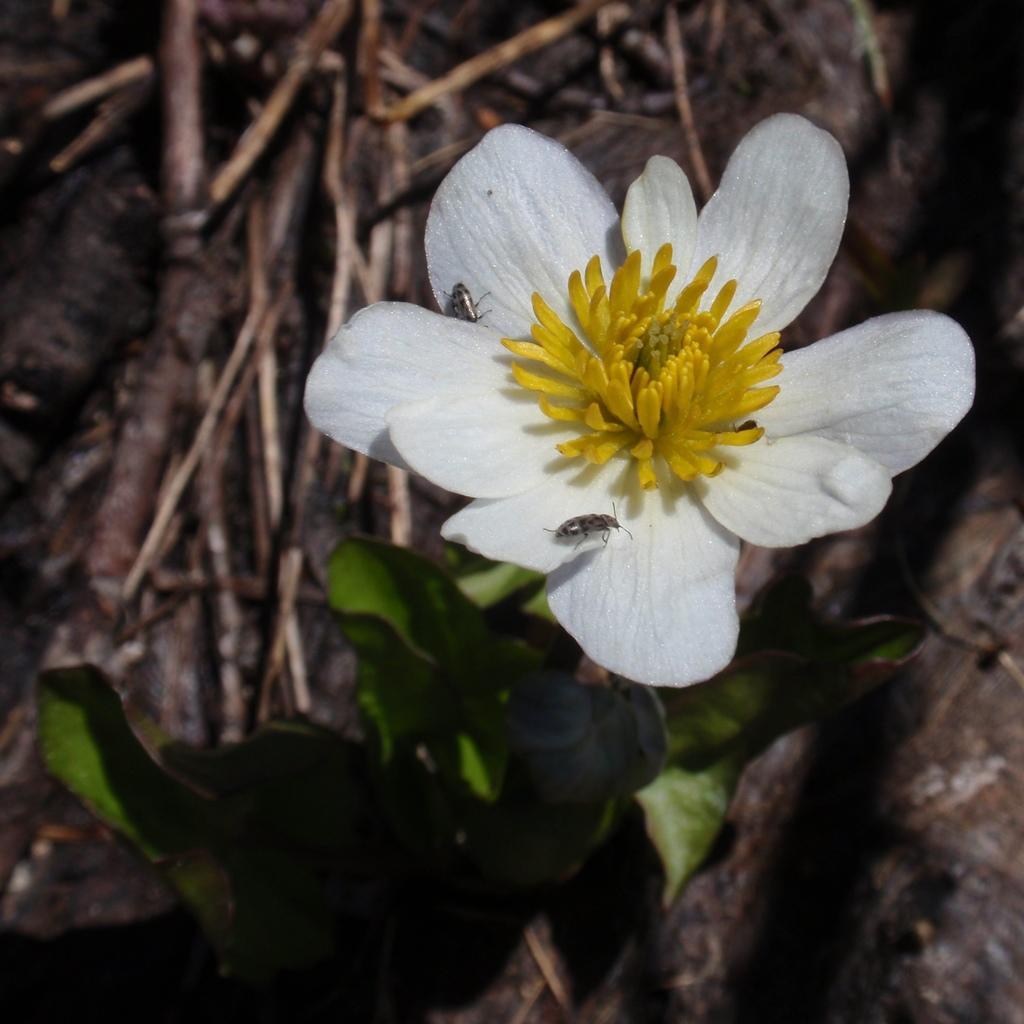Please provide a concise description of this image. In the image there is a flower with insects on it. Below the flower there are leaves. And there is a blur background with sticks. 